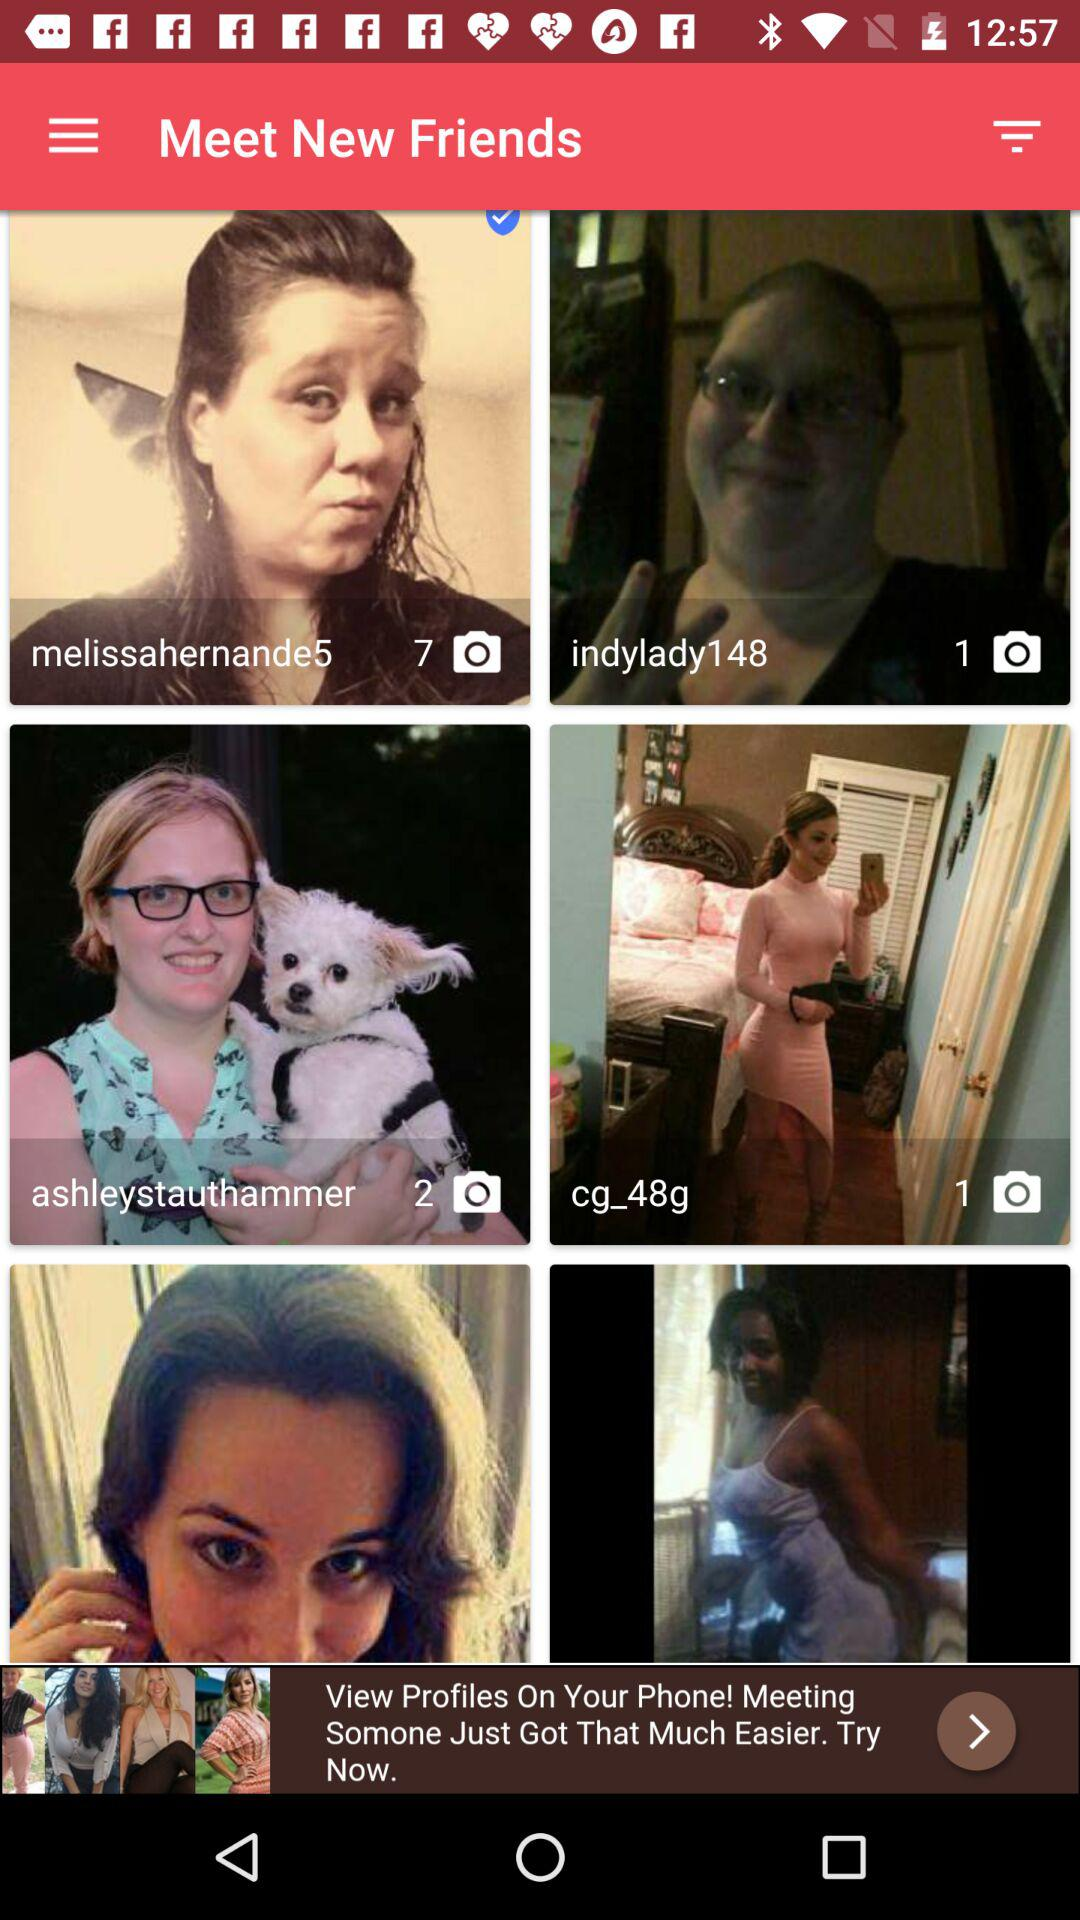What is the number of images in the "indylady148" folder? The number of images in the "indylady148" folder is 1. 